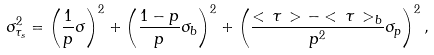Convert formula to latex. <formula><loc_0><loc_0><loc_500><loc_500>\sigma _ { \tau _ { s } } ^ { 2 } = \left ( \frac { 1 } { p } \sigma \right ) ^ { 2 } + \left ( \frac { 1 - p } { p } \sigma _ { b } \right ) ^ { 2 } + \left ( \frac { < \, \tau \, > - < \, \tau \, > _ { b } } { p ^ { 2 } } \sigma _ { p } \right ) ^ { 2 } ,</formula> 